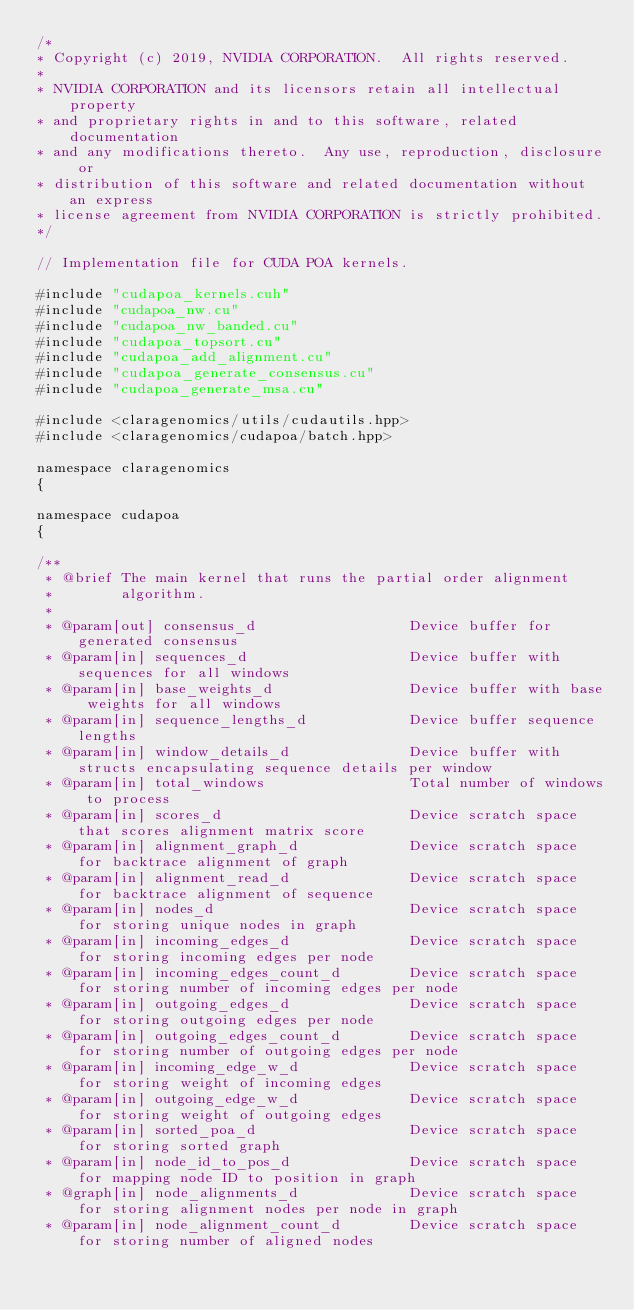<code> <loc_0><loc_0><loc_500><loc_500><_Cuda_>/*
* Copyright (c) 2019, NVIDIA CORPORATION.  All rights reserved.
*
* NVIDIA CORPORATION and its licensors retain all intellectual property
* and proprietary rights in and to this software, related documentation
* and any modifications thereto.  Any use, reproduction, disclosure or
* distribution of this software and related documentation without an express
* license agreement from NVIDIA CORPORATION is strictly prohibited.
*/

// Implementation file for CUDA POA kernels.

#include "cudapoa_kernels.cuh"
#include "cudapoa_nw.cu"
#include "cudapoa_nw_banded.cu"
#include "cudapoa_topsort.cu"
#include "cudapoa_add_alignment.cu"
#include "cudapoa_generate_consensus.cu"
#include "cudapoa_generate_msa.cu"

#include <claragenomics/utils/cudautils.hpp>
#include <claragenomics/cudapoa/batch.hpp>

namespace claragenomics
{

namespace cudapoa
{

/**
 * @brief The main kernel that runs the partial order alignment
 *        algorithm.
 *
 * @param[out] consensus_d                  Device buffer for generated consensus
 * @param[in] sequences_d                   Device buffer with sequences for all windows
 * @param[in] base_weights_d                Device buffer with base weights for all windows
 * @param[in] sequence_lengths_d            Device buffer sequence lengths
 * @param[in] window_details_d              Device buffer with structs encapsulating sequence details per window
 * @param[in] total_windows                 Total number of windows to process
 * @param[in] scores_d                      Device scratch space that scores alignment matrix score
 * @param[in] alignment_graph_d             Device scratch space for backtrace alignment of graph
 * @param[in] alignment_read_d              Device scratch space for backtrace alignment of sequence
 * @param[in] nodes_d                       Device scratch space for storing unique nodes in graph
 * @param[in] incoming_edges_d              Device scratch space for storing incoming edges per node
 * @param[in] incoming_edges_count_d        Device scratch space for storing number of incoming edges per node
 * @param[in] outgoing_edges_d              Device scratch space for storing outgoing edges per node
 * @param[in] outgoing_edges_count_d        Device scratch space for storing number of outgoing edges per node
 * @param[in] incoming_edge_w_d             Device scratch space for storing weight of incoming edges
 * @param[in] outgoing_edge_w_d             Device scratch space for storing weight of outgoing edges
 * @param[in] sorted_poa_d                  Device scratch space for storing sorted graph
 * @param[in] node_id_to_pos_d              Device scratch space for mapping node ID to position in graph
 * @graph[in] node_alignments_d             Device scratch space for storing alignment nodes per node in graph
 * @param[in] node_alignment_count_d        Device scratch space for storing number of aligned nodes</code> 